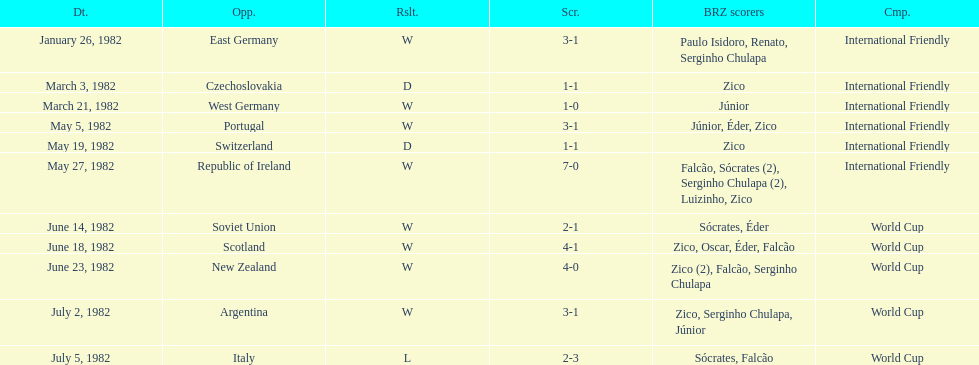What was the total number of losses brazil suffered? 1. 